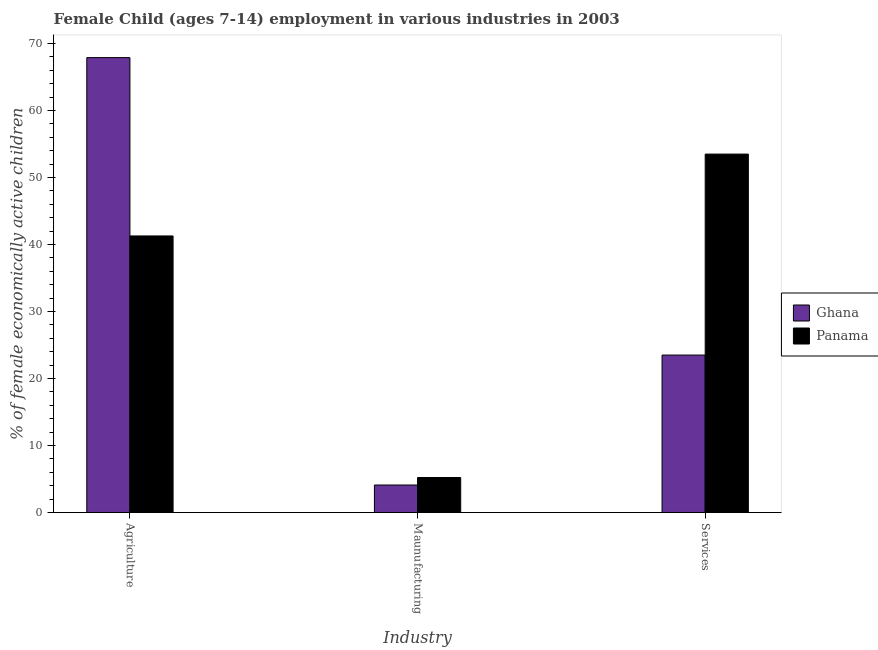Are the number of bars per tick equal to the number of legend labels?
Offer a terse response. Yes. How many bars are there on the 3rd tick from the left?
Offer a terse response. 2. What is the label of the 3rd group of bars from the left?
Offer a very short reply. Services. Across all countries, what is the maximum percentage of economically active children in manufacturing?
Offer a terse response. 5.22. Across all countries, what is the minimum percentage of economically active children in agriculture?
Your answer should be very brief. 41.28. In which country was the percentage of economically active children in manufacturing maximum?
Provide a short and direct response. Panama. In which country was the percentage of economically active children in agriculture minimum?
Offer a very short reply. Panama. What is the difference between the percentage of economically active children in manufacturing in Ghana and that in Panama?
Offer a terse response. -1.12. What is the difference between the percentage of economically active children in services in Panama and the percentage of economically active children in agriculture in Ghana?
Your answer should be very brief. -14.4. What is the average percentage of economically active children in services per country?
Provide a succinct answer. 38.5. What is the difference between the percentage of economically active children in services and percentage of economically active children in agriculture in Ghana?
Make the answer very short. -44.4. What is the ratio of the percentage of economically active children in services in Panama to that in Ghana?
Offer a very short reply. 2.28. Is the difference between the percentage of economically active children in services in Ghana and Panama greater than the difference between the percentage of economically active children in manufacturing in Ghana and Panama?
Your response must be concise. No. In how many countries, is the percentage of economically active children in agriculture greater than the average percentage of economically active children in agriculture taken over all countries?
Provide a succinct answer. 1. Is the sum of the percentage of economically active children in services in Ghana and Panama greater than the maximum percentage of economically active children in manufacturing across all countries?
Keep it short and to the point. Yes. What does the 2nd bar from the left in Maunufacturing represents?
Offer a terse response. Panama. What does the 1st bar from the right in Services represents?
Offer a terse response. Panama. Is it the case that in every country, the sum of the percentage of economically active children in agriculture and percentage of economically active children in manufacturing is greater than the percentage of economically active children in services?
Keep it short and to the point. No. How many bars are there?
Offer a very short reply. 6. Are all the bars in the graph horizontal?
Your answer should be compact. No. Are the values on the major ticks of Y-axis written in scientific E-notation?
Your answer should be very brief. No. Where does the legend appear in the graph?
Offer a terse response. Center right. How many legend labels are there?
Your answer should be very brief. 2. What is the title of the graph?
Offer a very short reply. Female Child (ages 7-14) employment in various industries in 2003. What is the label or title of the X-axis?
Provide a short and direct response. Industry. What is the label or title of the Y-axis?
Your answer should be very brief. % of female economically active children. What is the % of female economically active children of Ghana in Agriculture?
Offer a very short reply. 67.9. What is the % of female economically active children of Panama in Agriculture?
Provide a succinct answer. 41.28. What is the % of female economically active children of Panama in Maunufacturing?
Your answer should be very brief. 5.22. What is the % of female economically active children in Ghana in Services?
Offer a terse response. 23.5. What is the % of female economically active children of Panama in Services?
Your answer should be compact. 53.5. Across all Industry, what is the maximum % of female economically active children of Ghana?
Offer a terse response. 67.9. Across all Industry, what is the maximum % of female economically active children of Panama?
Your answer should be very brief. 53.5. Across all Industry, what is the minimum % of female economically active children of Panama?
Offer a very short reply. 5.22. What is the total % of female economically active children of Ghana in the graph?
Provide a short and direct response. 95.5. What is the difference between the % of female economically active children of Ghana in Agriculture and that in Maunufacturing?
Keep it short and to the point. 63.8. What is the difference between the % of female economically active children in Panama in Agriculture and that in Maunufacturing?
Ensure brevity in your answer.  36.06. What is the difference between the % of female economically active children in Ghana in Agriculture and that in Services?
Offer a very short reply. 44.4. What is the difference between the % of female economically active children of Panama in Agriculture and that in Services?
Ensure brevity in your answer.  -12.22. What is the difference between the % of female economically active children of Ghana in Maunufacturing and that in Services?
Your answer should be very brief. -19.4. What is the difference between the % of female economically active children of Panama in Maunufacturing and that in Services?
Provide a short and direct response. -48.28. What is the difference between the % of female economically active children in Ghana in Agriculture and the % of female economically active children in Panama in Maunufacturing?
Offer a very short reply. 62.68. What is the difference between the % of female economically active children of Ghana in Agriculture and the % of female economically active children of Panama in Services?
Offer a terse response. 14.4. What is the difference between the % of female economically active children in Ghana in Maunufacturing and the % of female economically active children in Panama in Services?
Give a very brief answer. -49.4. What is the average % of female economically active children in Ghana per Industry?
Provide a succinct answer. 31.83. What is the average % of female economically active children of Panama per Industry?
Your response must be concise. 33.33. What is the difference between the % of female economically active children in Ghana and % of female economically active children in Panama in Agriculture?
Your answer should be compact. 26.62. What is the difference between the % of female economically active children of Ghana and % of female economically active children of Panama in Maunufacturing?
Provide a short and direct response. -1.12. What is the ratio of the % of female economically active children of Ghana in Agriculture to that in Maunufacturing?
Your answer should be very brief. 16.56. What is the ratio of the % of female economically active children in Panama in Agriculture to that in Maunufacturing?
Give a very brief answer. 7.91. What is the ratio of the % of female economically active children of Ghana in Agriculture to that in Services?
Provide a short and direct response. 2.89. What is the ratio of the % of female economically active children in Panama in Agriculture to that in Services?
Give a very brief answer. 0.77. What is the ratio of the % of female economically active children of Ghana in Maunufacturing to that in Services?
Your response must be concise. 0.17. What is the ratio of the % of female economically active children of Panama in Maunufacturing to that in Services?
Make the answer very short. 0.1. What is the difference between the highest and the second highest % of female economically active children in Ghana?
Your answer should be very brief. 44.4. What is the difference between the highest and the second highest % of female economically active children of Panama?
Your response must be concise. 12.22. What is the difference between the highest and the lowest % of female economically active children of Ghana?
Your response must be concise. 63.8. What is the difference between the highest and the lowest % of female economically active children in Panama?
Offer a very short reply. 48.28. 